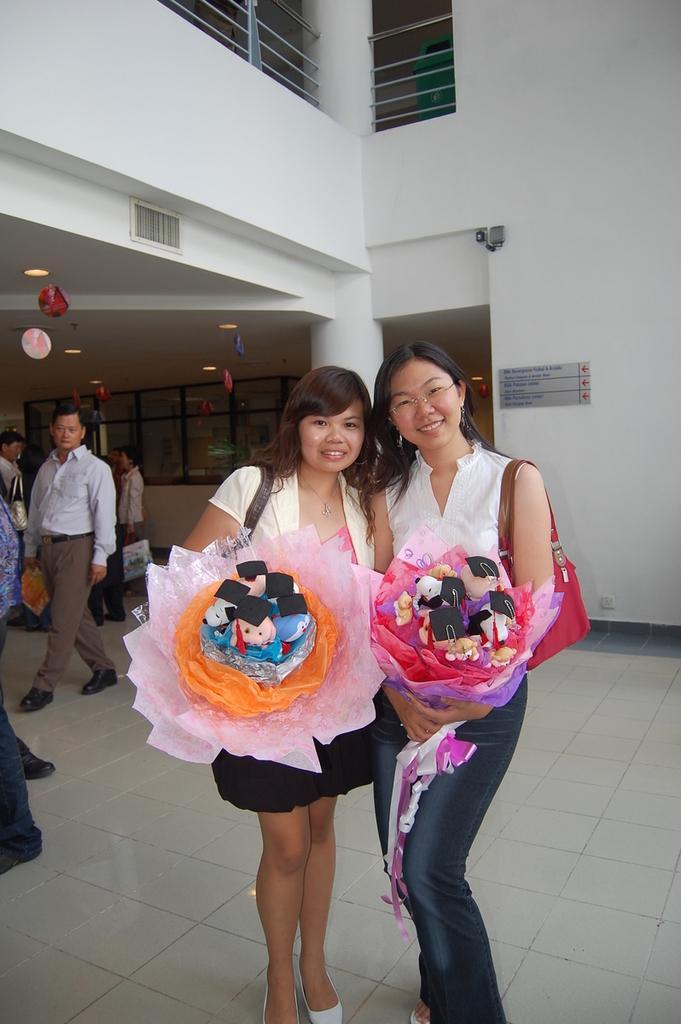Could you give a brief overview of what you see in this image? In this image, we can see persons wearing clothes. There are two persons in the middle of the image standing and holding bouquets with their hands. In the background, we can see a building. 